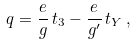<formula> <loc_0><loc_0><loc_500><loc_500>q = \frac { e } { g } \, t _ { 3 } - \frac { e } { g ^ { \prime } } \, t _ { Y } \, ,</formula> 